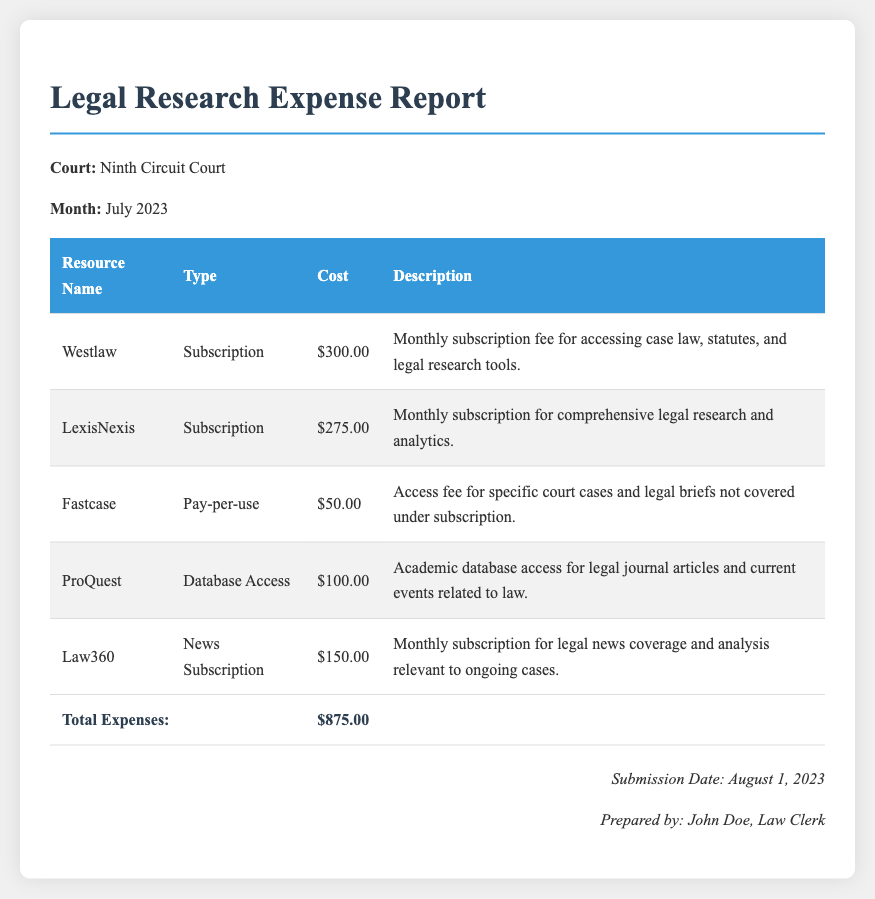What is the total expense for July 2023? The total expense is the sum of all individual resource costs listed in the table, which amounts to $875.00.
Answer: $875.00 Who prepared the expense report? The report indicates that it was prepared by John Doe, a Law Clerk.
Answer: John Doe How much was the subscription fee for LexisNexis? The document states that the subscription fee for LexisNexis was $275.00.
Answer: $275.00 What date was the report submitted? The footer of the report specifies that it was submitted on August 1, 2023.
Answer: August 1, 2023 What type of resource is Fastcase? The document describes Fastcase as a Pay-per-use resource type.
Answer: Pay-per-use What is the description of the ProQuest expense? The report details ProQuest as an academic database access for legal journal articles and current events related to law.
Answer: Academic database access for legal journal articles and current events related to law How many resources are listed in the report? By counting the entries in the table, there are five resources listed in the expense report.
Answer: Five What is the cost associated with Law360? The report specifies that the cost associated with Law360 is $150.00.
Answer: $150.00 What is the type of resource for Westlaw? The document classifies Westlaw as a Subscription type resource.
Answer: Subscription 